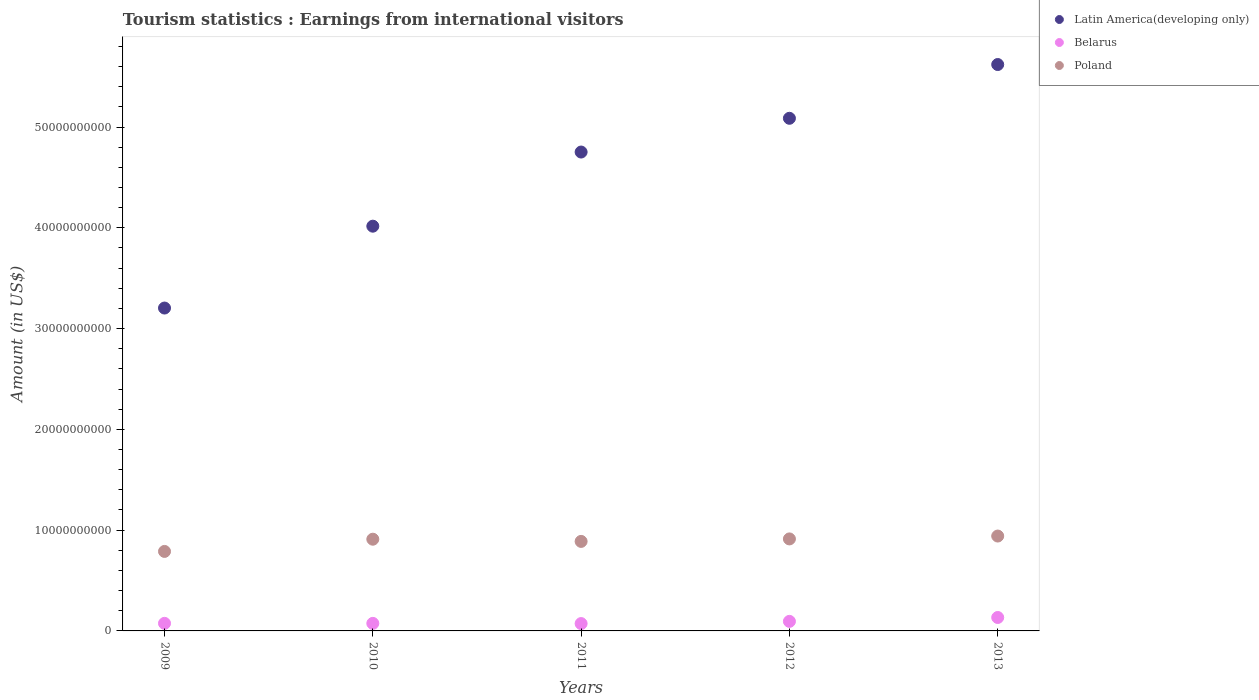Is the number of dotlines equal to the number of legend labels?
Offer a very short reply. Yes. What is the earnings from international visitors in Poland in 2009?
Ensure brevity in your answer.  7.89e+09. Across all years, what is the maximum earnings from international visitors in Belarus?
Offer a terse response. 1.33e+09. Across all years, what is the minimum earnings from international visitors in Belarus?
Give a very brief answer. 7.29e+08. In which year was the earnings from international visitors in Belarus maximum?
Provide a succinct answer. 2013. In which year was the earnings from international visitors in Belarus minimum?
Your answer should be compact. 2011. What is the total earnings from international visitors in Belarus in the graph?
Ensure brevity in your answer.  4.51e+09. What is the difference between the earnings from international visitors in Latin America(developing only) in 2009 and that in 2012?
Give a very brief answer. -1.88e+1. What is the difference between the earnings from international visitors in Latin America(developing only) in 2011 and the earnings from international visitors in Poland in 2010?
Your response must be concise. 3.84e+1. What is the average earnings from international visitors in Latin America(developing only) per year?
Your answer should be compact. 4.54e+1. In the year 2010, what is the difference between the earnings from international visitors in Belarus and earnings from international visitors in Poland?
Give a very brief answer. -8.35e+09. In how many years, is the earnings from international visitors in Poland greater than 50000000000 US$?
Provide a succinct answer. 0. What is the ratio of the earnings from international visitors in Poland in 2009 to that in 2010?
Offer a very short reply. 0.87. Is the earnings from international visitors in Poland in 2010 less than that in 2013?
Offer a very short reply. Yes. Is the difference between the earnings from international visitors in Belarus in 2009 and 2011 greater than the difference between the earnings from international visitors in Poland in 2009 and 2011?
Provide a short and direct response. Yes. What is the difference between the highest and the second highest earnings from international visitors in Latin America(developing only)?
Provide a short and direct response. 5.33e+09. What is the difference between the highest and the lowest earnings from international visitors in Belarus?
Offer a very short reply. 6.04e+08. Is the sum of the earnings from international visitors in Poland in 2010 and 2011 greater than the maximum earnings from international visitors in Latin America(developing only) across all years?
Offer a terse response. No. Is it the case that in every year, the sum of the earnings from international visitors in Belarus and earnings from international visitors in Latin America(developing only)  is greater than the earnings from international visitors in Poland?
Your answer should be compact. Yes. Does the earnings from international visitors in Latin America(developing only) monotonically increase over the years?
Keep it short and to the point. Yes. How many years are there in the graph?
Your response must be concise. 5. Are the values on the major ticks of Y-axis written in scientific E-notation?
Ensure brevity in your answer.  No. Does the graph contain grids?
Offer a very short reply. No. Where does the legend appear in the graph?
Provide a short and direct response. Top right. How many legend labels are there?
Your answer should be compact. 3. How are the legend labels stacked?
Offer a very short reply. Vertical. What is the title of the graph?
Offer a very short reply. Tourism statistics : Earnings from international visitors. Does "Guinea" appear as one of the legend labels in the graph?
Make the answer very short. No. What is the Amount (in US$) in Latin America(developing only) in 2009?
Your answer should be compact. 3.20e+1. What is the Amount (in US$) in Belarus in 2009?
Ensure brevity in your answer.  7.52e+08. What is the Amount (in US$) of Poland in 2009?
Make the answer very short. 7.89e+09. What is the Amount (in US$) of Latin America(developing only) in 2010?
Give a very brief answer. 4.02e+1. What is the Amount (in US$) in Belarus in 2010?
Your answer should be compact. 7.48e+08. What is the Amount (in US$) in Poland in 2010?
Your answer should be compact. 9.10e+09. What is the Amount (in US$) in Latin America(developing only) in 2011?
Provide a short and direct response. 4.75e+1. What is the Amount (in US$) in Belarus in 2011?
Keep it short and to the point. 7.29e+08. What is the Amount (in US$) in Poland in 2011?
Give a very brief answer. 8.88e+09. What is the Amount (in US$) of Latin America(developing only) in 2012?
Offer a very short reply. 5.09e+1. What is the Amount (in US$) of Belarus in 2012?
Your answer should be very brief. 9.48e+08. What is the Amount (in US$) of Poland in 2012?
Your response must be concise. 9.13e+09. What is the Amount (in US$) of Latin America(developing only) in 2013?
Your answer should be compact. 5.62e+1. What is the Amount (in US$) of Belarus in 2013?
Make the answer very short. 1.33e+09. What is the Amount (in US$) of Poland in 2013?
Offer a terse response. 9.41e+09. Across all years, what is the maximum Amount (in US$) in Latin America(developing only)?
Provide a succinct answer. 5.62e+1. Across all years, what is the maximum Amount (in US$) in Belarus?
Your response must be concise. 1.33e+09. Across all years, what is the maximum Amount (in US$) in Poland?
Your answer should be compact. 9.41e+09. Across all years, what is the minimum Amount (in US$) of Latin America(developing only)?
Provide a succinct answer. 3.20e+1. Across all years, what is the minimum Amount (in US$) in Belarus?
Your answer should be very brief. 7.29e+08. Across all years, what is the minimum Amount (in US$) in Poland?
Offer a very short reply. 7.89e+09. What is the total Amount (in US$) in Latin America(developing only) in the graph?
Provide a short and direct response. 2.27e+11. What is the total Amount (in US$) in Belarus in the graph?
Make the answer very short. 4.51e+09. What is the total Amount (in US$) of Poland in the graph?
Make the answer very short. 4.44e+1. What is the difference between the Amount (in US$) in Latin America(developing only) in 2009 and that in 2010?
Make the answer very short. -8.12e+09. What is the difference between the Amount (in US$) of Belarus in 2009 and that in 2010?
Ensure brevity in your answer.  4.00e+06. What is the difference between the Amount (in US$) of Poland in 2009 and that in 2010?
Offer a very short reply. -1.21e+09. What is the difference between the Amount (in US$) of Latin America(developing only) in 2009 and that in 2011?
Provide a short and direct response. -1.55e+1. What is the difference between the Amount (in US$) of Belarus in 2009 and that in 2011?
Offer a terse response. 2.30e+07. What is the difference between the Amount (in US$) of Poland in 2009 and that in 2011?
Give a very brief answer. -9.94e+08. What is the difference between the Amount (in US$) of Latin America(developing only) in 2009 and that in 2012?
Your response must be concise. -1.88e+1. What is the difference between the Amount (in US$) of Belarus in 2009 and that in 2012?
Provide a short and direct response. -1.96e+08. What is the difference between the Amount (in US$) in Poland in 2009 and that in 2012?
Offer a terse response. -1.24e+09. What is the difference between the Amount (in US$) of Latin America(developing only) in 2009 and that in 2013?
Provide a short and direct response. -2.42e+1. What is the difference between the Amount (in US$) of Belarus in 2009 and that in 2013?
Your answer should be very brief. -5.81e+08. What is the difference between the Amount (in US$) in Poland in 2009 and that in 2013?
Your answer should be compact. -1.53e+09. What is the difference between the Amount (in US$) of Latin America(developing only) in 2010 and that in 2011?
Your response must be concise. -7.36e+09. What is the difference between the Amount (in US$) in Belarus in 2010 and that in 2011?
Your answer should be compact. 1.90e+07. What is the difference between the Amount (in US$) of Poland in 2010 and that in 2011?
Provide a short and direct response. 2.18e+08. What is the difference between the Amount (in US$) of Latin America(developing only) in 2010 and that in 2012?
Your response must be concise. -1.07e+1. What is the difference between the Amount (in US$) of Belarus in 2010 and that in 2012?
Make the answer very short. -2.00e+08. What is the difference between the Amount (in US$) in Poland in 2010 and that in 2012?
Your answer should be very brief. -2.90e+07. What is the difference between the Amount (in US$) of Latin America(developing only) in 2010 and that in 2013?
Your answer should be very brief. -1.60e+1. What is the difference between the Amount (in US$) of Belarus in 2010 and that in 2013?
Ensure brevity in your answer.  -5.85e+08. What is the difference between the Amount (in US$) in Poland in 2010 and that in 2013?
Your answer should be very brief. -3.14e+08. What is the difference between the Amount (in US$) of Latin America(developing only) in 2011 and that in 2012?
Ensure brevity in your answer.  -3.35e+09. What is the difference between the Amount (in US$) in Belarus in 2011 and that in 2012?
Your answer should be compact. -2.19e+08. What is the difference between the Amount (in US$) of Poland in 2011 and that in 2012?
Your response must be concise. -2.47e+08. What is the difference between the Amount (in US$) of Latin America(developing only) in 2011 and that in 2013?
Give a very brief answer. -8.68e+09. What is the difference between the Amount (in US$) in Belarus in 2011 and that in 2013?
Provide a succinct answer. -6.04e+08. What is the difference between the Amount (in US$) in Poland in 2011 and that in 2013?
Offer a very short reply. -5.32e+08. What is the difference between the Amount (in US$) in Latin America(developing only) in 2012 and that in 2013?
Your answer should be compact. -5.33e+09. What is the difference between the Amount (in US$) in Belarus in 2012 and that in 2013?
Offer a terse response. -3.85e+08. What is the difference between the Amount (in US$) of Poland in 2012 and that in 2013?
Offer a terse response. -2.85e+08. What is the difference between the Amount (in US$) of Latin America(developing only) in 2009 and the Amount (in US$) of Belarus in 2010?
Keep it short and to the point. 3.13e+1. What is the difference between the Amount (in US$) of Latin America(developing only) in 2009 and the Amount (in US$) of Poland in 2010?
Offer a very short reply. 2.29e+1. What is the difference between the Amount (in US$) of Belarus in 2009 and the Amount (in US$) of Poland in 2010?
Offer a terse response. -8.35e+09. What is the difference between the Amount (in US$) in Latin America(developing only) in 2009 and the Amount (in US$) in Belarus in 2011?
Make the answer very short. 3.13e+1. What is the difference between the Amount (in US$) of Latin America(developing only) in 2009 and the Amount (in US$) of Poland in 2011?
Give a very brief answer. 2.32e+1. What is the difference between the Amount (in US$) in Belarus in 2009 and the Amount (in US$) in Poland in 2011?
Make the answer very short. -8.13e+09. What is the difference between the Amount (in US$) in Latin America(developing only) in 2009 and the Amount (in US$) in Belarus in 2012?
Provide a short and direct response. 3.11e+1. What is the difference between the Amount (in US$) of Latin America(developing only) in 2009 and the Amount (in US$) of Poland in 2012?
Provide a succinct answer. 2.29e+1. What is the difference between the Amount (in US$) in Belarus in 2009 and the Amount (in US$) in Poland in 2012?
Provide a succinct answer. -8.38e+09. What is the difference between the Amount (in US$) of Latin America(developing only) in 2009 and the Amount (in US$) of Belarus in 2013?
Your answer should be very brief. 3.07e+1. What is the difference between the Amount (in US$) of Latin America(developing only) in 2009 and the Amount (in US$) of Poland in 2013?
Make the answer very short. 2.26e+1. What is the difference between the Amount (in US$) in Belarus in 2009 and the Amount (in US$) in Poland in 2013?
Ensure brevity in your answer.  -8.66e+09. What is the difference between the Amount (in US$) in Latin America(developing only) in 2010 and the Amount (in US$) in Belarus in 2011?
Provide a succinct answer. 3.94e+1. What is the difference between the Amount (in US$) of Latin America(developing only) in 2010 and the Amount (in US$) of Poland in 2011?
Your answer should be compact. 3.13e+1. What is the difference between the Amount (in US$) in Belarus in 2010 and the Amount (in US$) in Poland in 2011?
Your response must be concise. -8.13e+09. What is the difference between the Amount (in US$) in Latin America(developing only) in 2010 and the Amount (in US$) in Belarus in 2012?
Offer a very short reply. 3.92e+1. What is the difference between the Amount (in US$) in Latin America(developing only) in 2010 and the Amount (in US$) in Poland in 2012?
Keep it short and to the point. 3.10e+1. What is the difference between the Amount (in US$) of Belarus in 2010 and the Amount (in US$) of Poland in 2012?
Ensure brevity in your answer.  -8.38e+09. What is the difference between the Amount (in US$) in Latin America(developing only) in 2010 and the Amount (in US$) in Belarus in 2013?
Your answer should be compact. 3.88e+1. What is the difference between the Amount (in US$) of Latin America(developing only) in 2010 and the Amount (in US$) of Poland in 2013?
Your response must be concise. 3.07e+1. What is the difference between the Amount (in US$) of Belarus in 2010 and the Amount (in US$) of Poland in 2013?
Provide a succinct answer. -8.67e+09. What is the difference between the Amount (in US$) of Latin America(developing only) in 2011 and the Amount (in US$) of Belarus in 2012?
Provide a succinct answer. 4.66e+1. What is the difference between the Amount (in US$) in Latin America(developing only) in 2011 and the Amount (in US$) in Poland in 2012?
Make the answer very short. 3.84e+1. What is the difference between the Amount (in US$) in Belarus in 2011 and the Amount (in US$) in Poland in 2012?
Provide a short and direct response. -8.40e+09. What is the difference between the Amount (in US$) in Latin America(developing only) in 2011 and the Amount (in US$) in Belarus in 2013?
Your answer should be very brief. 4.62e+1. What is the difference between the Amount (in US$) in Latin America(developing only) in 2011 and the Amount (in US$) in Poland in 2013?
Ensure brevity in your answer.  3.81e+1. What is the difference between the Amount (in US$) of Belarus in 2011 and the Amount (in US$) of Poland in 2013?
Offer a terse response. -8.68e+09. What is the difference between the Amount (in US$) of Latin America(developing only) in 2012 and the Amount (in US$) of Belarus in 2013?
Provide a short and direct response. 4.95e+1. What is the difference between the Amount (in US$) in Latin America(developing only) in 2012 and the Amount (in US$) in Poland in 2013?
Make the answer very short. 4.15e+1. What is the difference between the Amount (in US$) of Belarus in 2012 and the Amount (in US$) of Poland in 2013?
Provide a short and direct response. -8.47e+09. What is the average Amount (in US$) of Latin America(developing only) per year?
Your response must be concise. 4.54e+1. What is the average Amount (in US$) of Belarus per year?
Your answer should be very brief. 9.02e+08. What is the average Amount (in US$) of Poland per year?
Your answer should be very brief. 8.88e+09. In the year 2009, what is the difference between the Amount (in US$) in Latin America(developing only) and Amount (in US$) in Belarus?
Your response must be concise. 3.13e+1. In the year 2009, what is the difference between the Amount (in US$) of Latin America(developing only) and Amount (in US$) of Poland?
Offer a very short reply. 2.41e+1. In the year 2009, what is the difference between the Amount (in US$) of Belarus and Amount (in US$) of Poland?
Give a very brief answer. -7.14e+09. In the year 2010, what is the difference between the Amount (in US$) in Latin America(developing only) and Amount (in US$) in Belarus?
Make the answer very short. 3.94e+1. In the year 2010, what is the difference between the Amount (in US$) in Latin America(developing only) and Amount (in US$) in Poland?
Offer a very short reply. 3.11e+1. In the year 2010, what is the difference between the Amount (in US$) in Belarus and Amount (in US$) in Poland?
Make the answer very short. -8.35e+09. In the year 2011, what is the difference between the Amount (in US$) of Latin America(developing only) and Amount (in US$) of Belarus?
Keep it short and to the point. 4.68e+1. In the year 2011, what is the difference between the Amount (in US$) in Latin America(developing only) and Amount (in US$) in Poland?
Give a very brief answer. 3.86e+1. In the year 2011, what is the difference between the Amount (in US$) in Belarus and Amount (in US$) in Poland?
Offer a very short reply. -8.15e+09. In the year 2012, what is the difference between the Amount (in US$) of Latin America(developing only) and Amount (in US$) of Belarus?
Offer a terse response. 4.99e+1. In the year 2012, what is the difference between the Amount (in US$) in Latin America(developing only) and Amount (in US$) in Poland?
Make the answer very short. 4.17e+1. In the year 2012, what is the difference between the Amount (in US$) in Belarus and Amount (in US$) in Poland?
Give a very brief answer. -8.18e+09. In the year 2013, what is the difference between the Amount (in US$) of Latin America(developing only) and Amount (in US$) of Belarus?
Provide a succinct answer. 5.49e+1. In the year 2013, what is the difference between the Amount (in US$) in Latin America(developing only) and Amount (in US$) in Poland?
Offer a terse response. 4.68e+1. In the year 2013, what is the difference between the Amount (in US$) of Belarus and Amount (in US$) of Poland?
Your answer should be compact. -8.08e+09. What is the ratio of the Amount (in US$) of Latin America(developing only) in 2009 to that in 2010?
Make the answer very short. 0.8. What is the ratio of the Amount (in US$) of Poland in 2009 to that in 2010?
Offer a very short reply. 0.87. What is the ratio of the Amount (in US$) in Latin America(developing only) in 2009 to that in 2011?
Your response must be concise. 0.67. What is the ratio of the Amount (in US$) in Belarus in 2009 to that in 2011?
Your response must be concise. 1.03. What is the ratio of the Amount (in US$) in Poland in 2009 to that in 2011?
Give a very brief answer. 0.89. What is the ratio of the Amount (in US$) in Latin America(developing only) in 2009 to that in 2012?
Offer a very short reply. 0.63. What is the ratio of the Amount (in US$) of Belarus in 2009 to that in 2012?
Offer a terse response. 0.79. What is the ratio of the Amount (in US$) of Poland in 2009 to that in 2012?
Provide a succinct answer. 0.86. What is the ratio of the Amount (in US$) in Latin America(developing only) in 2009 to that in 2013?
Offer a very short reply. 0.57. What is the ratio of the Amount (in US$) of Belarus in 2009 to that in 2013?
Give a very brief answer. 0.56. What is the ratio of the Amount (in US$) in Poland in 2009 to that in 2013?
Ensure brevity in your answer.  0.84. What is the ratio of the Amount (in US$) of Latin America(developing only) in 2010 to that in 2011?
Keep it short and to the point. 0.85. What is the ratio of the Amount (in US$) of Belarus in 2010 to that in 2011?
Your answer should be very brief. 1.03. What is the ratio of the Amount (in US$) of Poland in 2010 to that in 2011?
Provide a short and direct response. 1.02. What is the ratio of the Amount (in US$) in Latin America(developing only) in 2010 to that in 2012?
Ensure brevity in your answer.  0.79. What is the ratio of the Amount (in US$) in Belarus in 2010 to that in 2012?
Your answer should be compact. 0.79. What is the ratio of the Amount (in US$) of Poland in 2010 to that in 2012?
Provide a short and direct response. 1. What is the ratio of the Amount (in US$) of Latin America(developing only) in 2010 to that in 2013?
Give a very brief answer. 0.71. What is the ratio of the Amount (in US$) of Belarus in 2010 to that in 2013?
Your response must be concise. 0.56. What is the ratio of the Amount (in US$) of Poland in 2010 to that in 2013?
Your response must be concise. 0.97. What is the ratio of the Amount (in US$) in Latin America(developing only) in 2011 to that in 2012?
Provide a succinct answer. 0.93. What is the ratio of the Amount (in US$) of Belarus in 2011 to that in 2012?
Provide a short and direct response. 0.77. What is the ratio of the Amount (in US$) of Poland in 2011 to that in 2012?
Provide a succinct answer. 0.97. What is the ratio of the Amount (in US$) of Latin America(developing only) in 2011 to that in 2013?
Keep it short and to the point. 0.85. What is the ratio of the Amount (in US$) in Belarus in 2011 to that in 2013?
Give a very brief answer. 0.55. What is the ratio of the Amount (in US$) of Poland in 2011 to that in 2013?
Offer a very short reply. 0.94. What is the ratio of the Amount (in US$) of Latin America(developing only) in 2012 to that in 2013?
Your answer should be very brief. 0.91. What is the ratio of the Amount (in US$) of Belarus in 2012 to that in 2013?
Your answer should be very brief. 0.71. What is the ratio of the Amount (in US$) of Poland in 2012 to that in 2013?
Give a very brief answer. 0.97. What is the difference between the highest and the second highest Amount (in US$) of Latin America(developing only)?
Make the answer very short. 5.33e+09. What is the difference between the highest and the second highest Amount (in US$) of Belarus?
Your answer should be very brief. 3.85e+08. What is the difference between the highest and the second highest Amount (in US$) of Poland?
Your response must be concise. 2.85e+08. What is the difference between the highest and the lowest Amount (in US$) in Latin America(developing only)?
Provide a short and direct response. 2.42e+1. What is the difference between the highest and the lowest Amount (in US$) in Belarus?
Provide a short and direct response. 6.04e+08. What is the difference between the highest and the lowest Amount (in US$) of Poland?
Provide a succinct answer. 1.53e+09. 